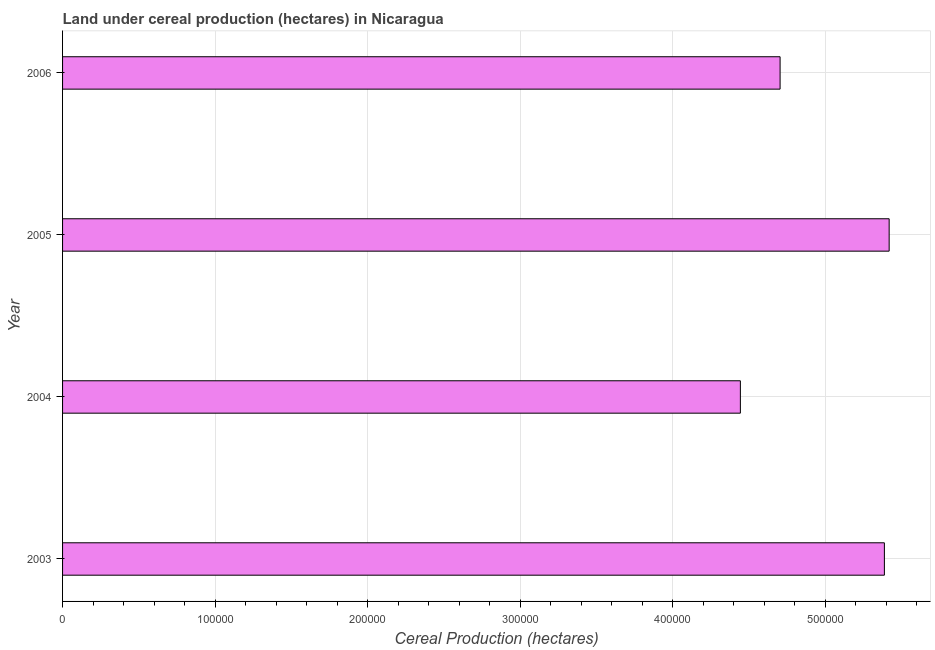What is the title of the graph?
Offer a very short reply. Land under cereal production (hectares) in Nicaragua. What is the label or title of the X-axis?
Offer a terse response. Cereal Production (hectares). What is the land under cereal production in 2005?
Make the answer very short. 5.42e+05. Across all years, what is the maximum land under cereal production?
Offer a terse response. 5.42e+05. Across all years, what is the minimum land under cereal production?
Offer a terse response. 4.44e+05. In which year was the land under cereal production maximum?
Offer a terse response. 2005. In which year was the land under cereal production minimum?
Provide a short and direct response. 2004. What is the sum of the land under cereal production?
Your response must be concise. 1.99e+06. What is the difference between the land under cereal production in 2004 and 2006?
Give a very brief answer. -2.60e+04. What is the average land under cereal production per year?
Offer a terse response. 4.99e+05. What is the median land under cereal production?
Offer a terse response. 5.04e+05. Do a majority of the years between 2006 and 2004 (inclusive) have land under cereal production greater than 480000 hectares?
Keep it short and to the point. Yes. What is the ratio of the land under cereal production in 2004 to that in 2006?
Your response must be concise. 0.94. Is the land under cereal production in 2003 less than that in 2004?
Ensure brevity in your answer.  No. What is the difference between the highest and the second highest land under cereal production?
Offer a terse response. 3125. Is the sum of the land under cereal production in 2004 and 2005 greater than the maximum land under cereal production across all years?
Keep it short and to the point. Yes. What is the difference between the highest and the lowest land under cereal production?
Provide a short and direct response. 9.75e+04. In how many years, is the land under cereal production greater than the average land under cereal production taken over all years?
Give a very brief answer. 2. What is the Cereal Production (hectares) of 2003?
Offer a very short reply. 5.39e+05. What is the Cereal Production (hectares) of 2004?
Provide a short and direct response. 4.44e+05. What is the Cereal Production (hectares) of 2005?
Your response must be concise. 5.42e+05. What is the Cereal Production (hectares) of 2006?
Provide a short and direct response. 4.70e+05. What is the difference between the Cereal Production (hectares) in 2003 and 2004?
Your answer should be very brief. 9.44e+04. What is the difference between the Cereal Production (hectares) in 2003 and 2005?
Provide a short and direct response. -3125. What is the difference between the Cereal Production (hectares) in 2003 and 2006?
Your answer should be compact. 6.84e+04. What is the difference between the Cereal Production (hectares) in 2004 and 2005?
Ensure brevity in your answer.  -9.75e+04. What is the difference between the Cereal Production (hectares) in 2004 and 2006?
Keep it short and to the point. -2.60e+04. What is the difference between the Cereal Production (hectares) in 2005 and 2006?
Your answer should be very brief. 7.15e+04. What is the ratio of the Cereal Production (hectares) in 2003 to that in 2004?
Provide a succinct answer. 1.21. What is the ratio of the Cereal Production (hectares) in 2003 to that in 2006?
Keep it short and to the point. 1.15. What is the ratio of the Cereal Production (hectares) in 2004 to that in 2005?
Provide a succinct answer. 0.82. What is the ratio of the Cereal Production (hectares) in 2004 to that in 2006?
Keep it short and to the point. 0.94. What is the ratio of the Cereal Production (hectares) in 2005 to that in 2006?
Offer a very short reply. 1.15. 